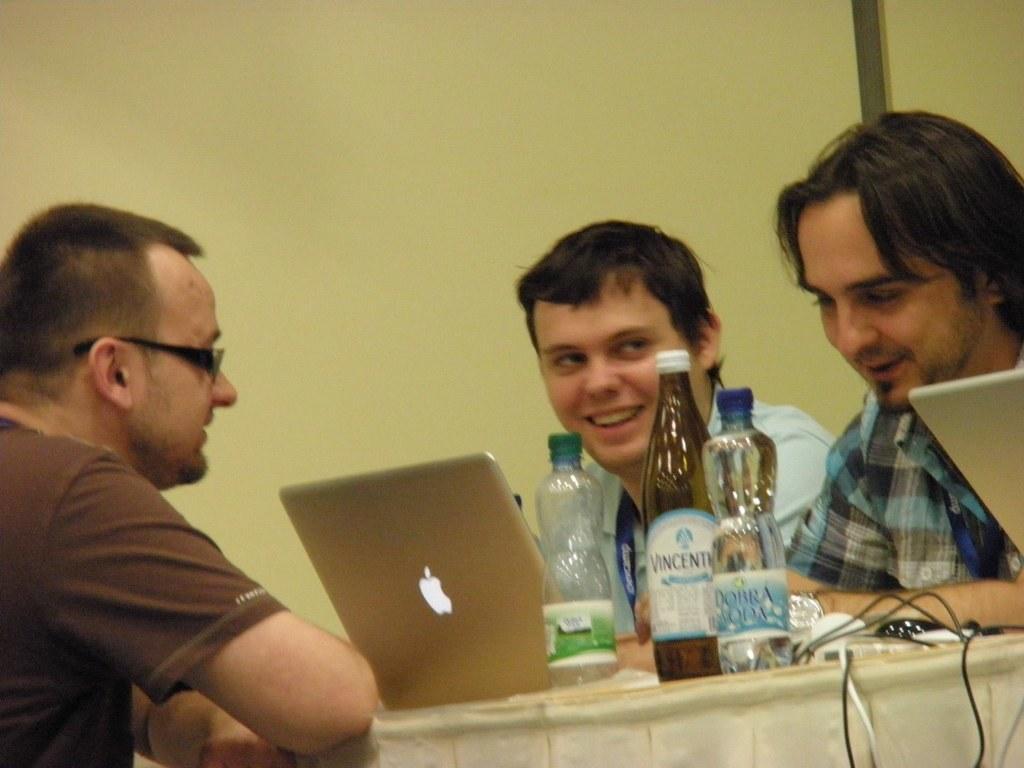How would you summarize this image in a sentence or two? This picture shows three men sitting on the chair and we see three bottles and couple of laptops on the table and we see smile on their faces and a man wore spectacles on his face 